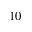Convert formula to latex. <formula><loc_0><loc_0><loc_500><loc_500>_ { 1 0 }</formula> 